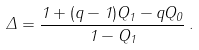Convert formula to latex. <formula><loc_0><loc_0><loc_500><loc_500>\Delta = \frac { 1 + ( q - 1 ) Q _ { 1 } - q Q _ { 0 } } { 1 - Q _ { 1 } } \, .</formula> 